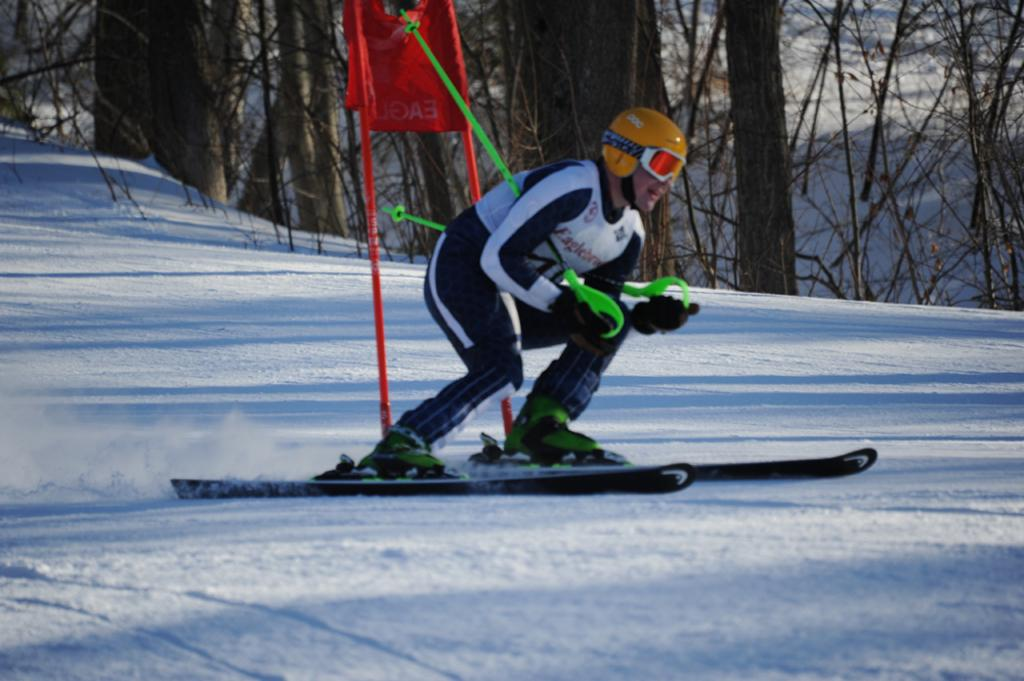What activity is the person in the image engaged in? The person is doing ice skating. What protective gear is the person wearing? The person is wearing a helmet and goggles. What is the person holding in their hands? The person is holding two sticks. What can be seen in the background of the image? There are trees and a stand visible in the background of the image. What time is displayed on the clock in the image? There is no clock present in the image. How many people are in jail in the image? There is no jail or any indication of incarceration in the image. 